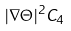Convert formula to latex. <formula><loc_0><loc_0><loc_500><loc_500>| \nabla \Theta | ^ { 2 } C _ { 4 }</formula> 